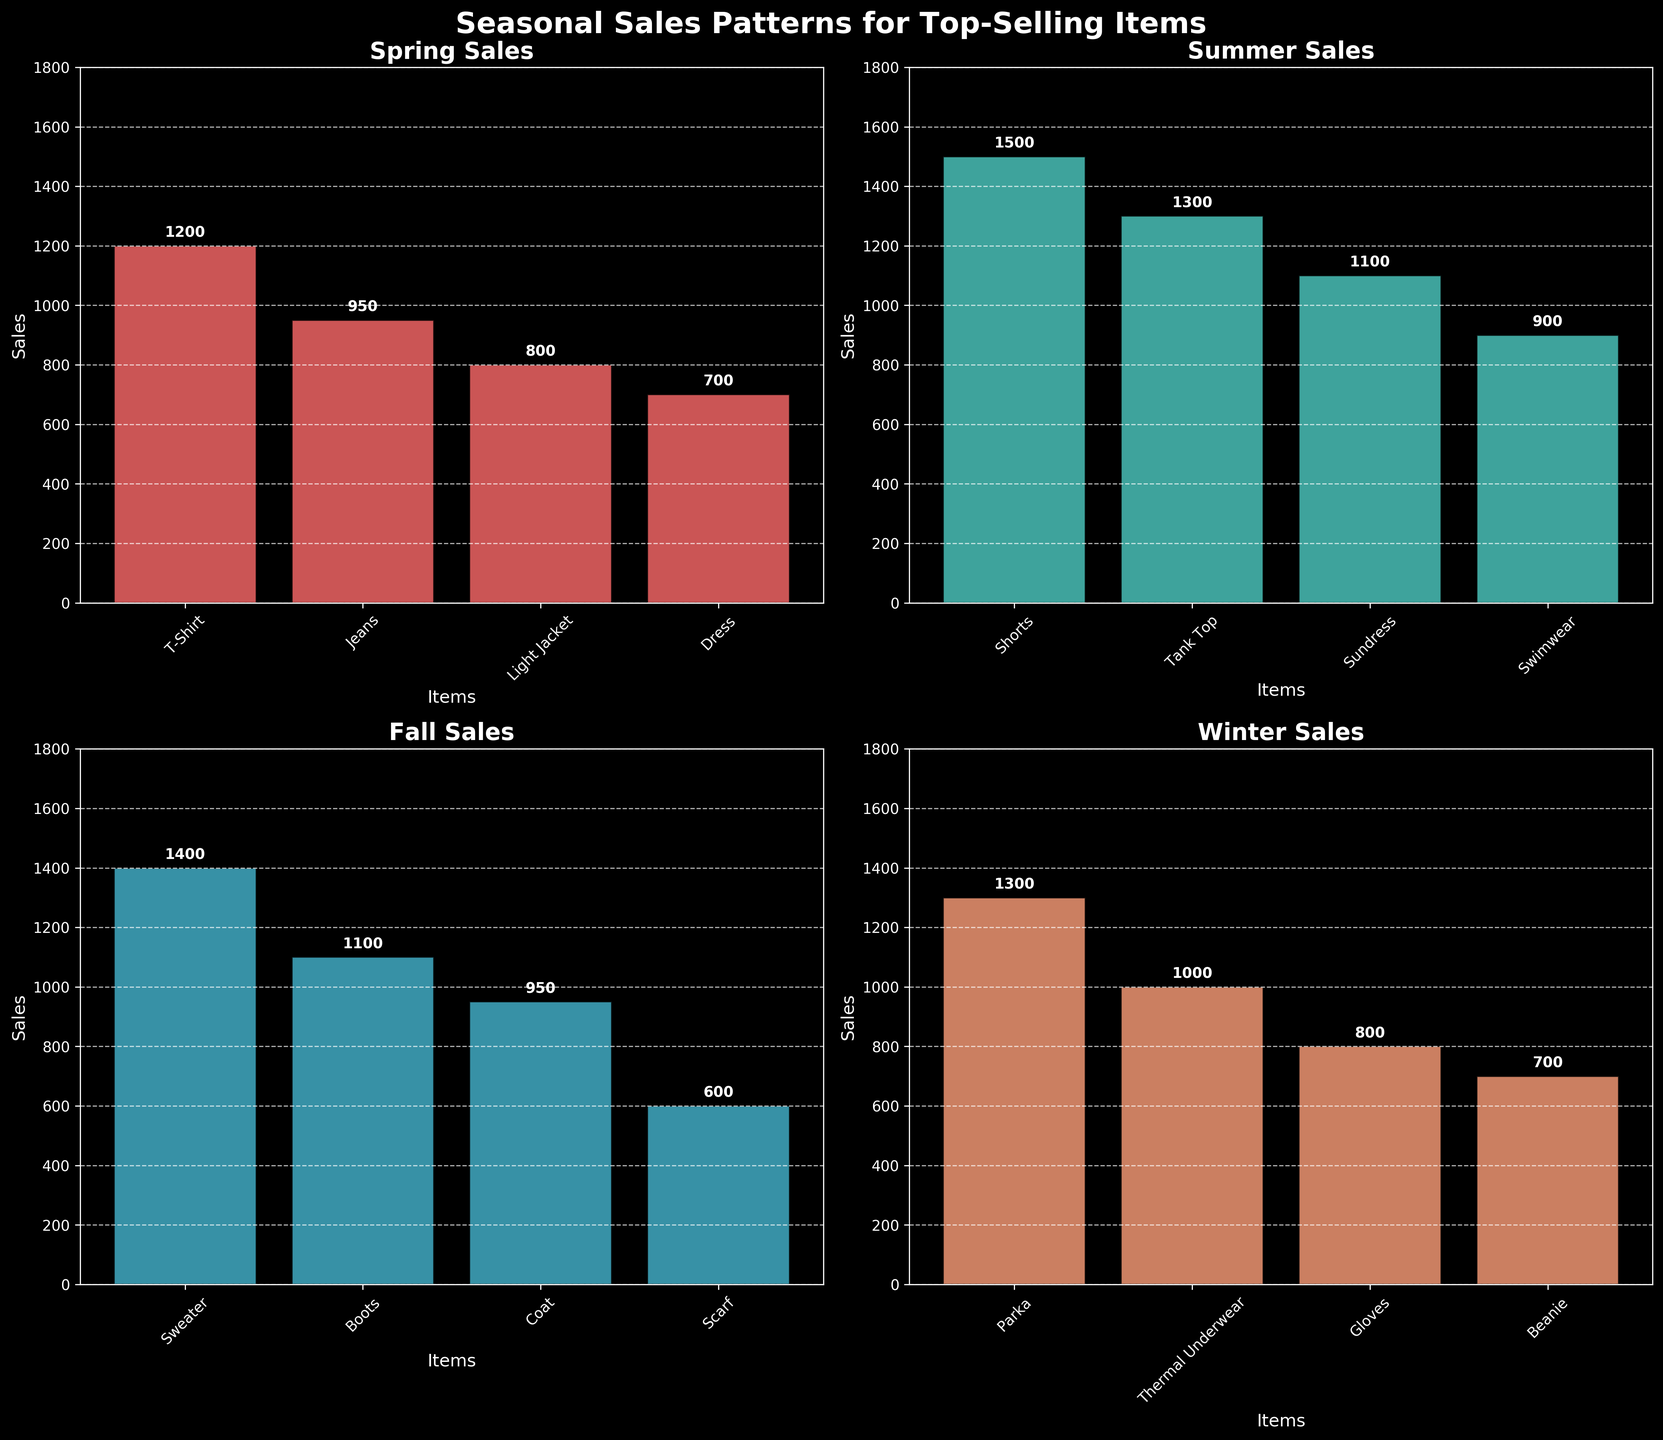What is the title of the figure? The title is placed at the top of the entire figure and is in bold text. It usually summarizes the main focus of the figure.
Answer: Seasonal Sales Patterns for Top-Selling Items Which item had the highest sales in Fall? Look for the Fall subplot and identify the bar that reaches the highest point in that plot.
Answer: Sweater How do the Summer sales of Tank Top compare to Sundress? Observe the heights of the bars for Tank Top and Sundress in the Summer subplot. The Tank Top bar is higher than the Sundress bar.
Answer: Tank Top sales are higher than Sundress sales What is the combined sales total for Spring items? Sum the heights of all bars (sales values) in the Spring subplot: 1200 (T-Shirt) + 950 (Jeans) + 800 (Light Jacket) + 700 (Dress).
Answer: 3650 Which season has the lowest sales for the top-selling Swimwear item? Check the Swimwear bar in the Summer subplot, then compare it to the lowest bars in the other subplots.
Answer: Winter, no Swimwear sales Are the sales of T-Shirts in Spring higher or lower than the sales of Shorts in Summer? Compare the heights of the T-Shirt bar in Spring and the Shorts bar in Summer. The Shorts bar is higher than the T-Shirt bar.
Answer: Shorts sales in Summer are higher than T-Shirt sales in Spring What's the average sales figure for Winter items? Add the sales figures for Winter items and divide by the number of Winter items: (1300 (Parka) + 1000 (Thermal Underwear) + 800 (Gloves) + 700 (Beanie)) / 4.
Answer: 950 Which season has the most consistent sales across its top-selling items? Look for the season where bars in the subplot are closest in height to each other.
Answer: Winter Is there an item that consistently appears in every season’s top-selling list? Check each subplot to see if any item appears in all four subplots.
Answer: No What percentage of the total sales for Fall is represented by Boots? Calculate the total sales for Fall and then the percentage of Boots: 1100 (Boots) / (1400 (Sweater) + 1100 (Boots) + 950 (Coat) + 600 (Scarf)) × 100%.
Answer: 29.73% 